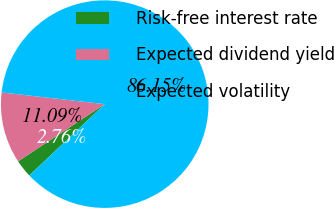Convert chart. <chart><loc_0><loc_0><loc_500><loc_500><pie_chart><fcel>Risk-free interest rate<fcel>Expected dividend yield<fcel>Expected volatility<nl><fcel>2.76%<fcel>11.09%<fcel>86.15%<nl></chart> 